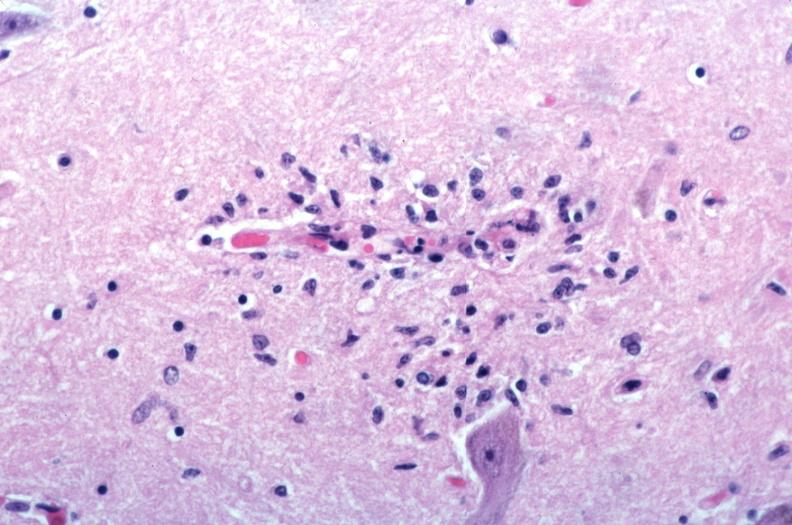does this image show brain?
Answer the question using a single word or phrase. Yes 